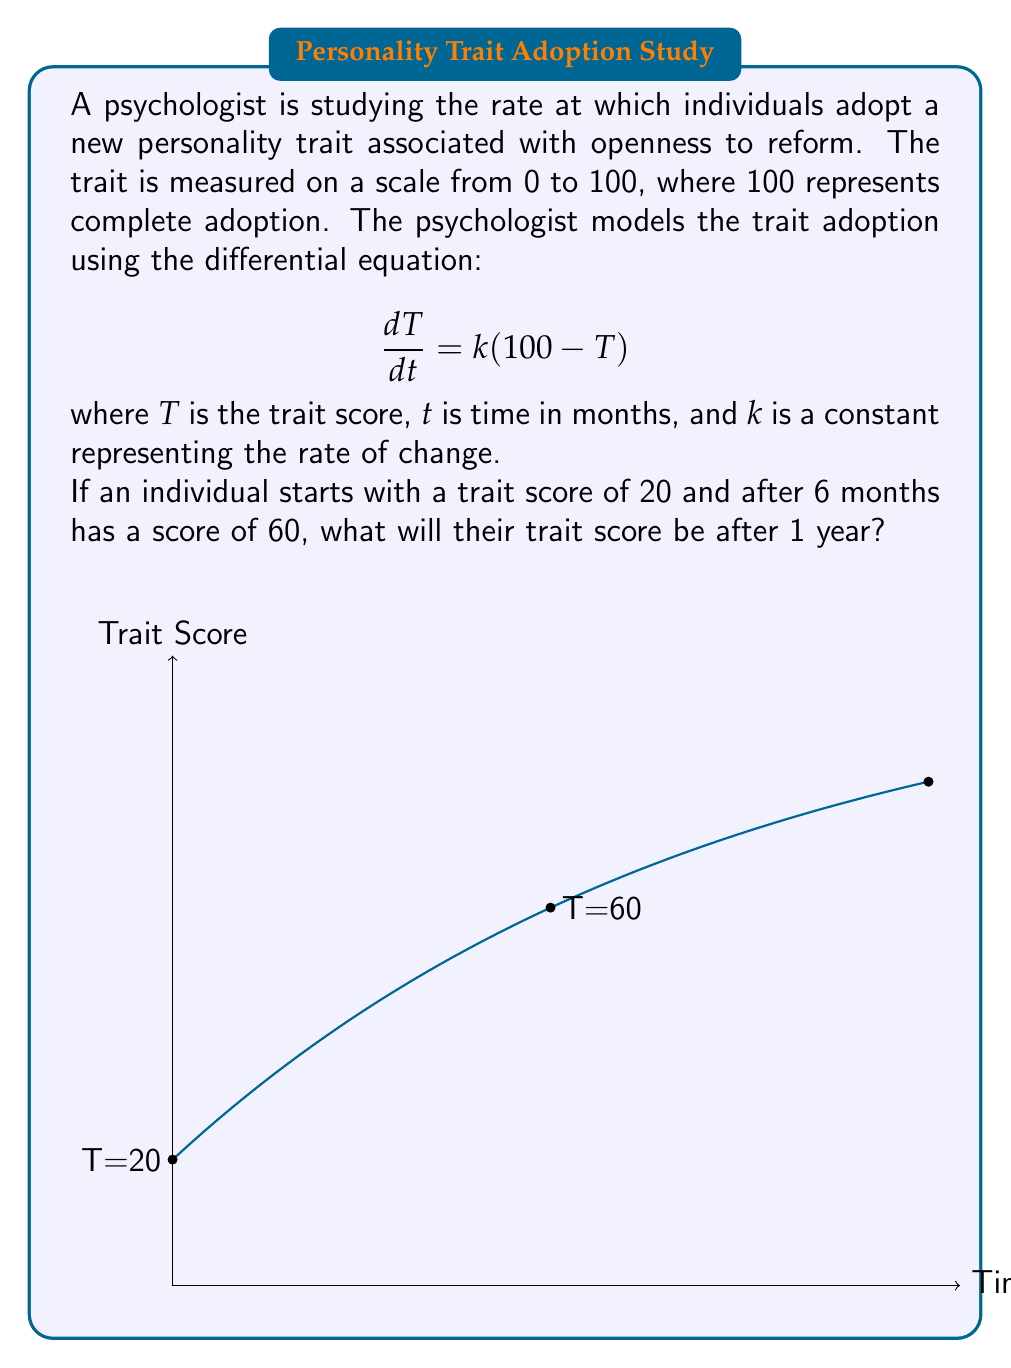Can you solve this math problem? Let's solve this step-by-step:

1) The general solution to this differential equation is:
   $$T = 100 - Ce^{-kt}$$
   where $C$ is a constant of integration.

2) Using the initial condition $T(0) = 20$:
   $$20 = 100 - C$$
   $$C = 80$$

3) So our specific solution is:
   $$T = 100 - 80e^{-kt}$$

4) Now we can use the condition that $T(6) = 60$ to find $k$:
   $$60 = 100 - 80e^{-6k}$$
   $$40 = 80e^{-6k}$$
   $$0.5 = e^{-6k}$$
   $$\ln(0.5) = -6k$$
   $$k = \frac{-\ln(0.5)}{6} \approx 0.1155$$

5) Now we have our complete model:
   $$T = 100 - 80e^{-0.1155t}$$

6) To find the trait score after 1 year (12 months), we substitute $t=12$:
   $$T(12) = 100 - 80e^{-0.1155(12)} \approx 82.45$$
Answer: 82.45 